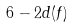<formula> <loc_0><loc_0><loc_500><loc_500>6 - 2 d ( f )</formula> 